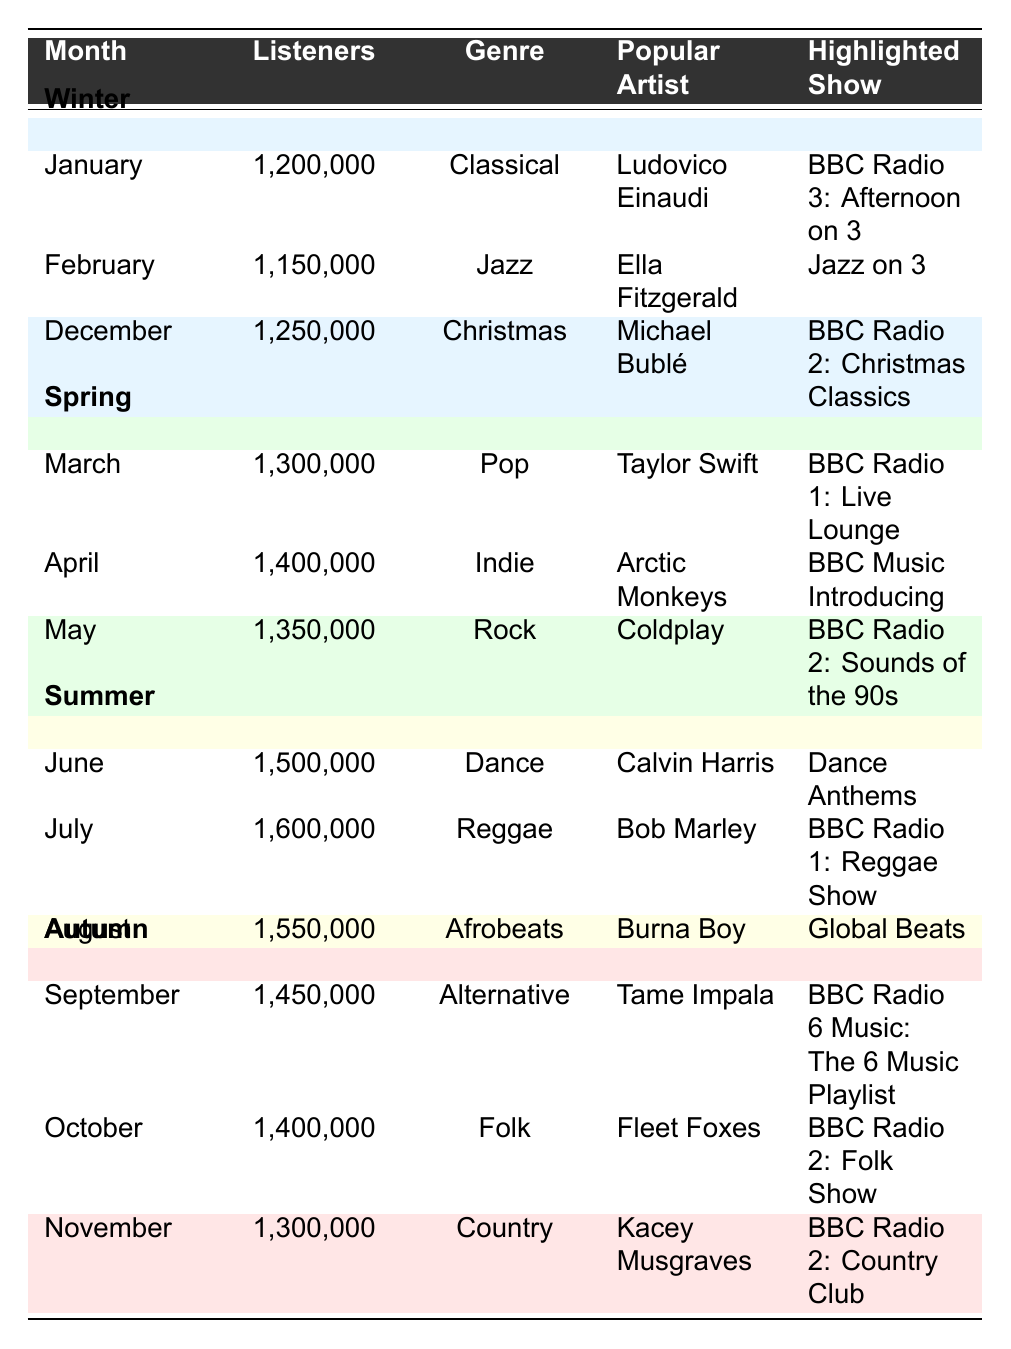What is the most played genre in December? The most played genre in December can be found in the row for that month, which indicates "Christmas" as the genre.
Answer: Christmas Which month had the highest listener count? By looking at the listener counts for each month, July has the highest count at 1,600,000 listeners.
Answer: July How many listeners tuned in during the Spring months combined? The listener counts for March, April, and May are 1,300,000, 1,400,000, and 1,350,000 respectively. Adding these gives 1,300,000 + 1,400,000 + 1,350,000 = 4,050,000.
Answer: 4,050,000 In which season did Bob Marley gain the most listeners? Bob Marley is featured in July (Summer), which has the highest listener count of 1,600,000 compared to other artists in different seasons. This implies he had the most listeners in Summer.
Answer: Summer What was the genre of the most popular artist in August? In August, the popular artist is Burna Boy, whose genre is identified as "Afrobeats."
Answer: Afrobeats Is January more popular than February based on listener count? January has 1,200,000 listeners, while February has 1,150,000. Since 1,200,000 is greater than 1,150,000, January is indeed more popular than February.
Answer: Yes Which genre has the least number of listeners in the Winter season? In the Winter months, the genres are Classical, Jazz, and Christmas. By comparing the listener counts: 1,200,000 (Classical), 1,150,000 (Jazz), and 1,250,000 (Christmas), Jazz has the least count at 1,150,000.
Answer: Jazz What is the average listener count for all the months listed in the table? The total listener count for all months is 1,200,000 + 1,150,000 + 1,300,000 + 1,400,000 + 1,350,000 + 1,500,000 + 1,600,000 + 1,550,000 + 1,450,000 + 1,400,000 + 1,300,000 + 1,250,000 = 15,200,000. There are 12 months, so the average is 15,200,000 / 12 = 1,266,667.
Answer: 1,266,667 Which highlighted show featured the artist Kacey Musgraves? The highlighted show featuring Kacey Musgraves is identified in November, which corresponds to "BBC Radio 2: Country Club."
Answer: BBC Radio 2: Country Club During which season was the genre "Indie" most listened to? The genre "Indie" appears in April, which is noted to be in the Spring season. Therefore, Spring is the season where Indie was most listened to.
Answer: Spring What was the most played genre in the Summer months? The most played genres during the Summer are Dance in June, Reggae in July, and Afrobeats in August. Among these, Dance is the genre played in June which had 1,500,000 listeners, indicating it's the most played during Summer.
Answer: Dance 